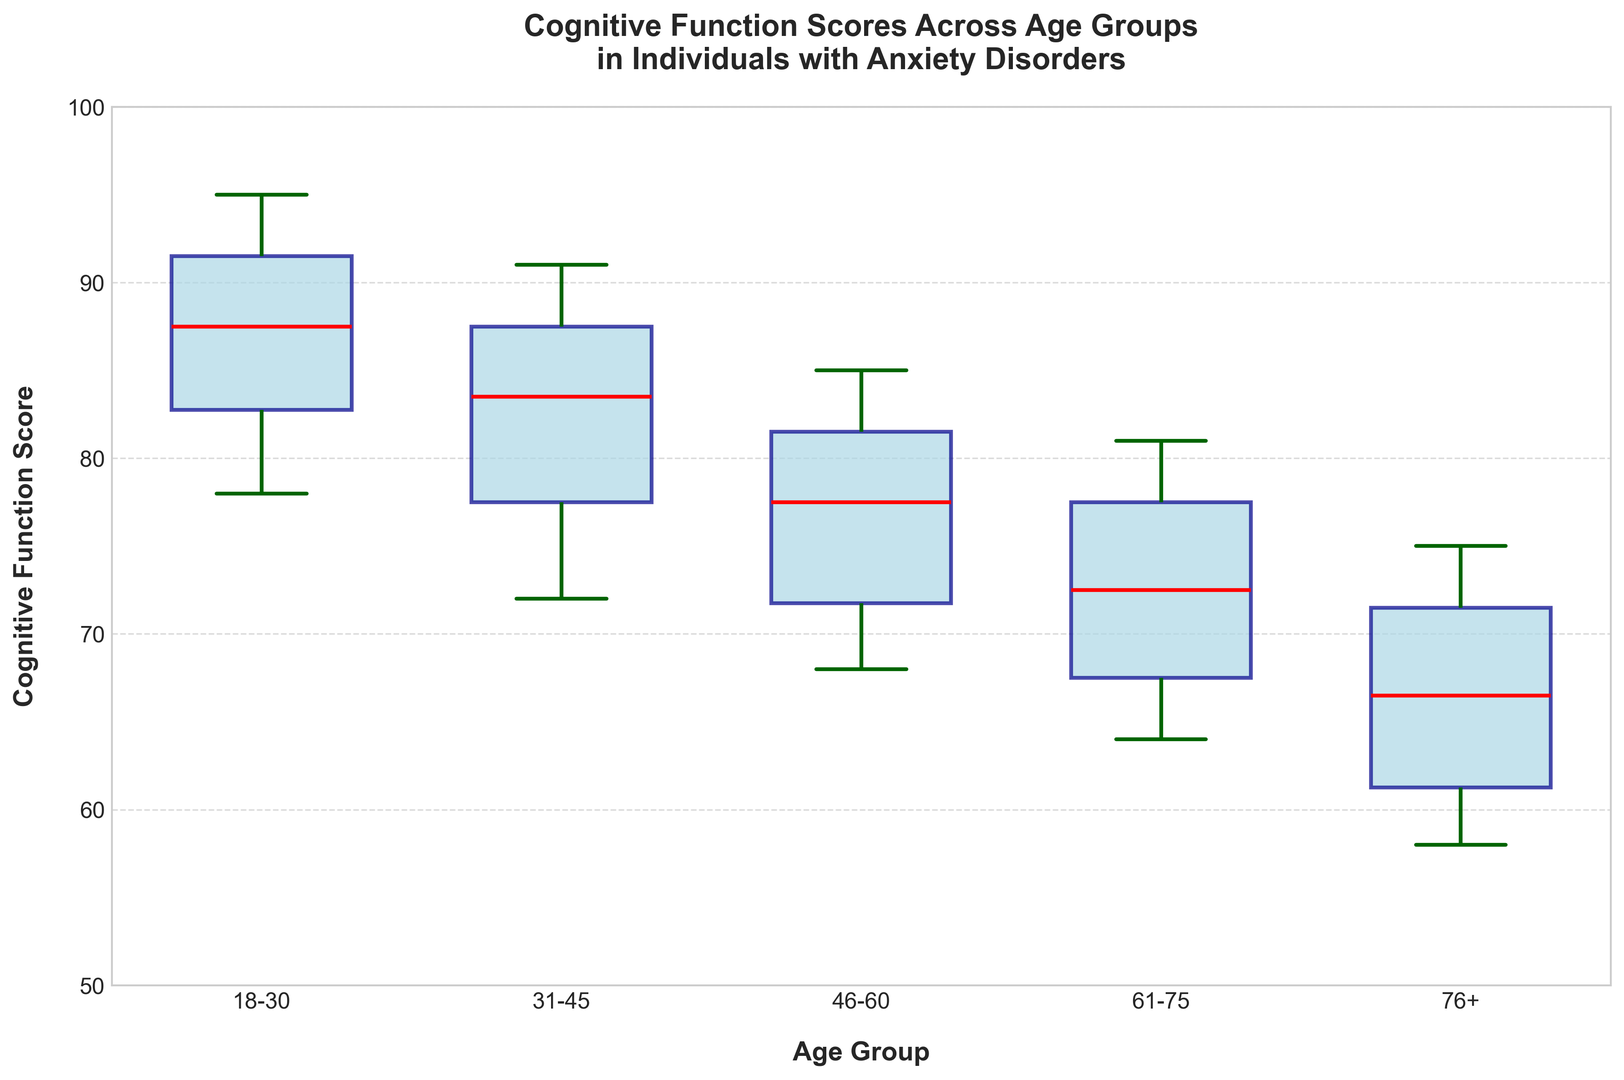Which age group has the highest median Cognitive Function Score? The median line within the box for the 18-30 age group is the highest among all age groups.
Answer: 18-30 How does the median Cognitive Function Score for the 31-45 age group compare to the 46-60 age group? The median line within the box for the 31-45 age group is higher than that for the 46-60 age group.
Answer: Higher What is the range of Cognitive Function Scores for the 61-75 age group? The range is the difference between the highest and lowest whiskers of the 61-75 age group. The highest whisker is at 81, and the lowest is at 64. Therefore, the range is 81 - 64 = 17.
Answer: 17 Which age group shows the most variability in Cognitive Function Scores? Variability can be interpreted by the length of the boxes and whiskers. The 76+ age group shows the widest spread between its whiskers and a relatively long box, indicating high variability.
Answer: 76+ What is the interquartile range (IQR) of Cognitive Function Scores in the 18-30 age group? The IQR is the difference between the 75th percentile (top of the box) and the 25th percentile (bottom of the box). For the 18-30 age group, the top of the box is around 92, and the bottom is around 85. The IQR is 92 - 85 = 7.
Answer: 7 How do the whiskers' lengths of the 46-60 age group compare to those of the 18-30 age group? The whiskers' lengths indicate the range of data spread. The 46-60 group has whiskers from approximately 68 to 85 (length of 17), while the 18-30 group extends from around 78 to 95 (length of 17). Both have the same whisker length.
Answer: Same Does any age group have outliers in the Cognitive Function Scores? Outliers are typically indicated by individual points outside the whiskers. None of the age groups show individual points outside the whiskers.
Answer: No What is the position of the median compared to the top and bottom of the box for the 61-75 age group? The median line within the box for 61-75 is closer to the top of the box, indicating a right-skewed distribution within this age group.
Answer: Closer to the top Which color represents the 76+ age group in the plot? Each age group box is shaded differently, and the 76+ age group is represented by the fifth box. In a viridis palette, it corresponds to a shade near violet-pink.
Answer: Violet-Pink 